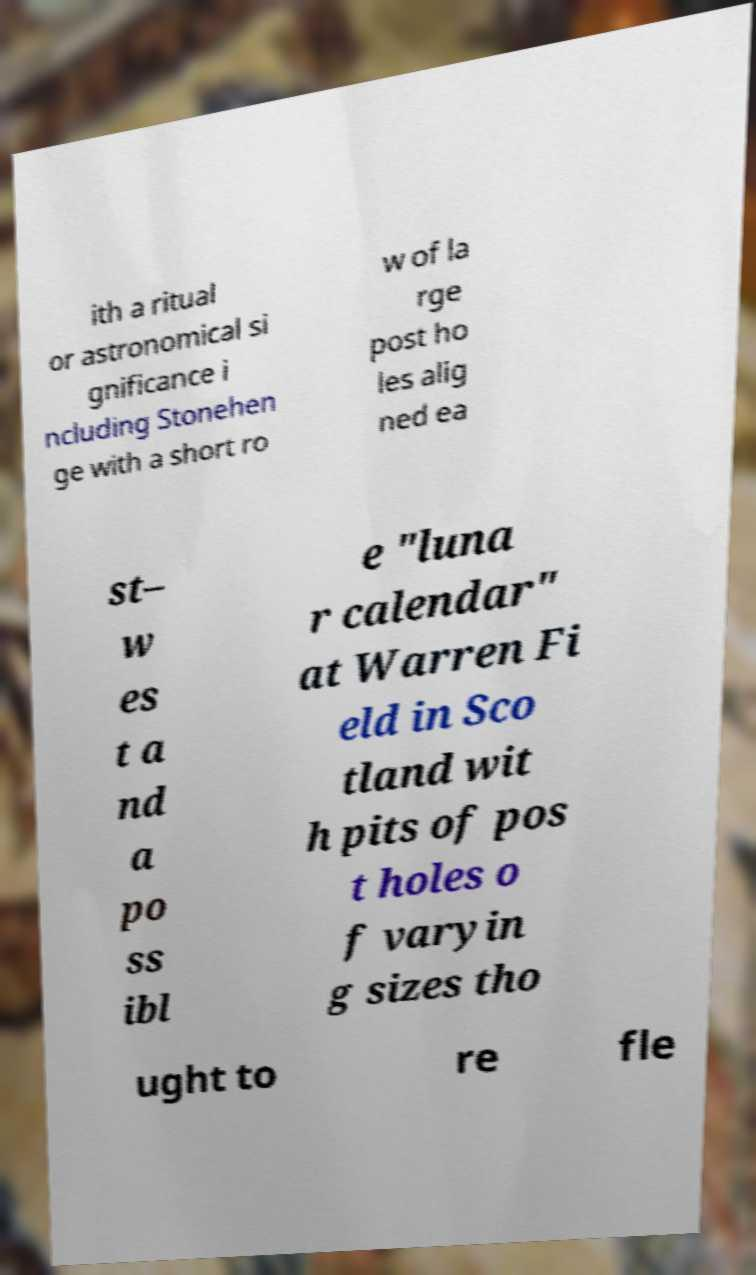What messages or text are displayed in this image? I need them in a readable, typed format. ith a ritual or astronomical si gnificance i ncluding Stonehen ge with a short ro w of la rge post ho les alig ned ea st– w es t a nd a po ss ibl e "luna r calendar" at Warren Fi eld in Sco tland wit h pits of pos t holes o f varyin g sizes tho ught to re fle 